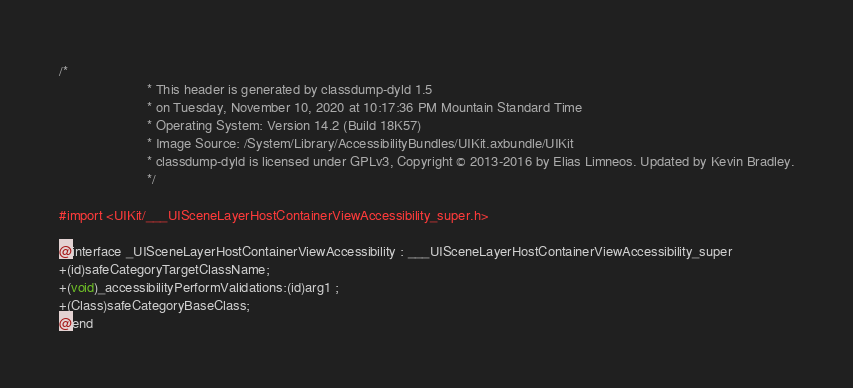Convert code to text. <code><loc_0><loc_0><loc_500><loc_500><_C_>/*
                       * This header is generated by classdump-dyld 1.5
                       * on Tuesday, November 10, 2020 at 10:17:36 PM Mountain Standard Time
                       * Operating System: Version 14.2 (Build 18K57)
                       * Image Source: /System/Library/AccessibilityBundles/UIKit.axbundle/UIKit
                       * classdump-dyld is licensed under GPLv3, Copyright © 2013-2016 by Elias Limneos. Updated by Kevin Bradley.
                       */

#import <UIKit/___UISceneLayerHostContainerViewAccessibility_super.h>

@interface _UISceneLayerHostContainerViewAccessibility : ___UISceneLayerHostContainerViewAccessibility_super
+(id)safeCategoryTargetClassName;
+(void)_accessibilityPerformValidations:(id)arg1 ;
+(Class)safeCategoryBaseClass;
@end

</code> 